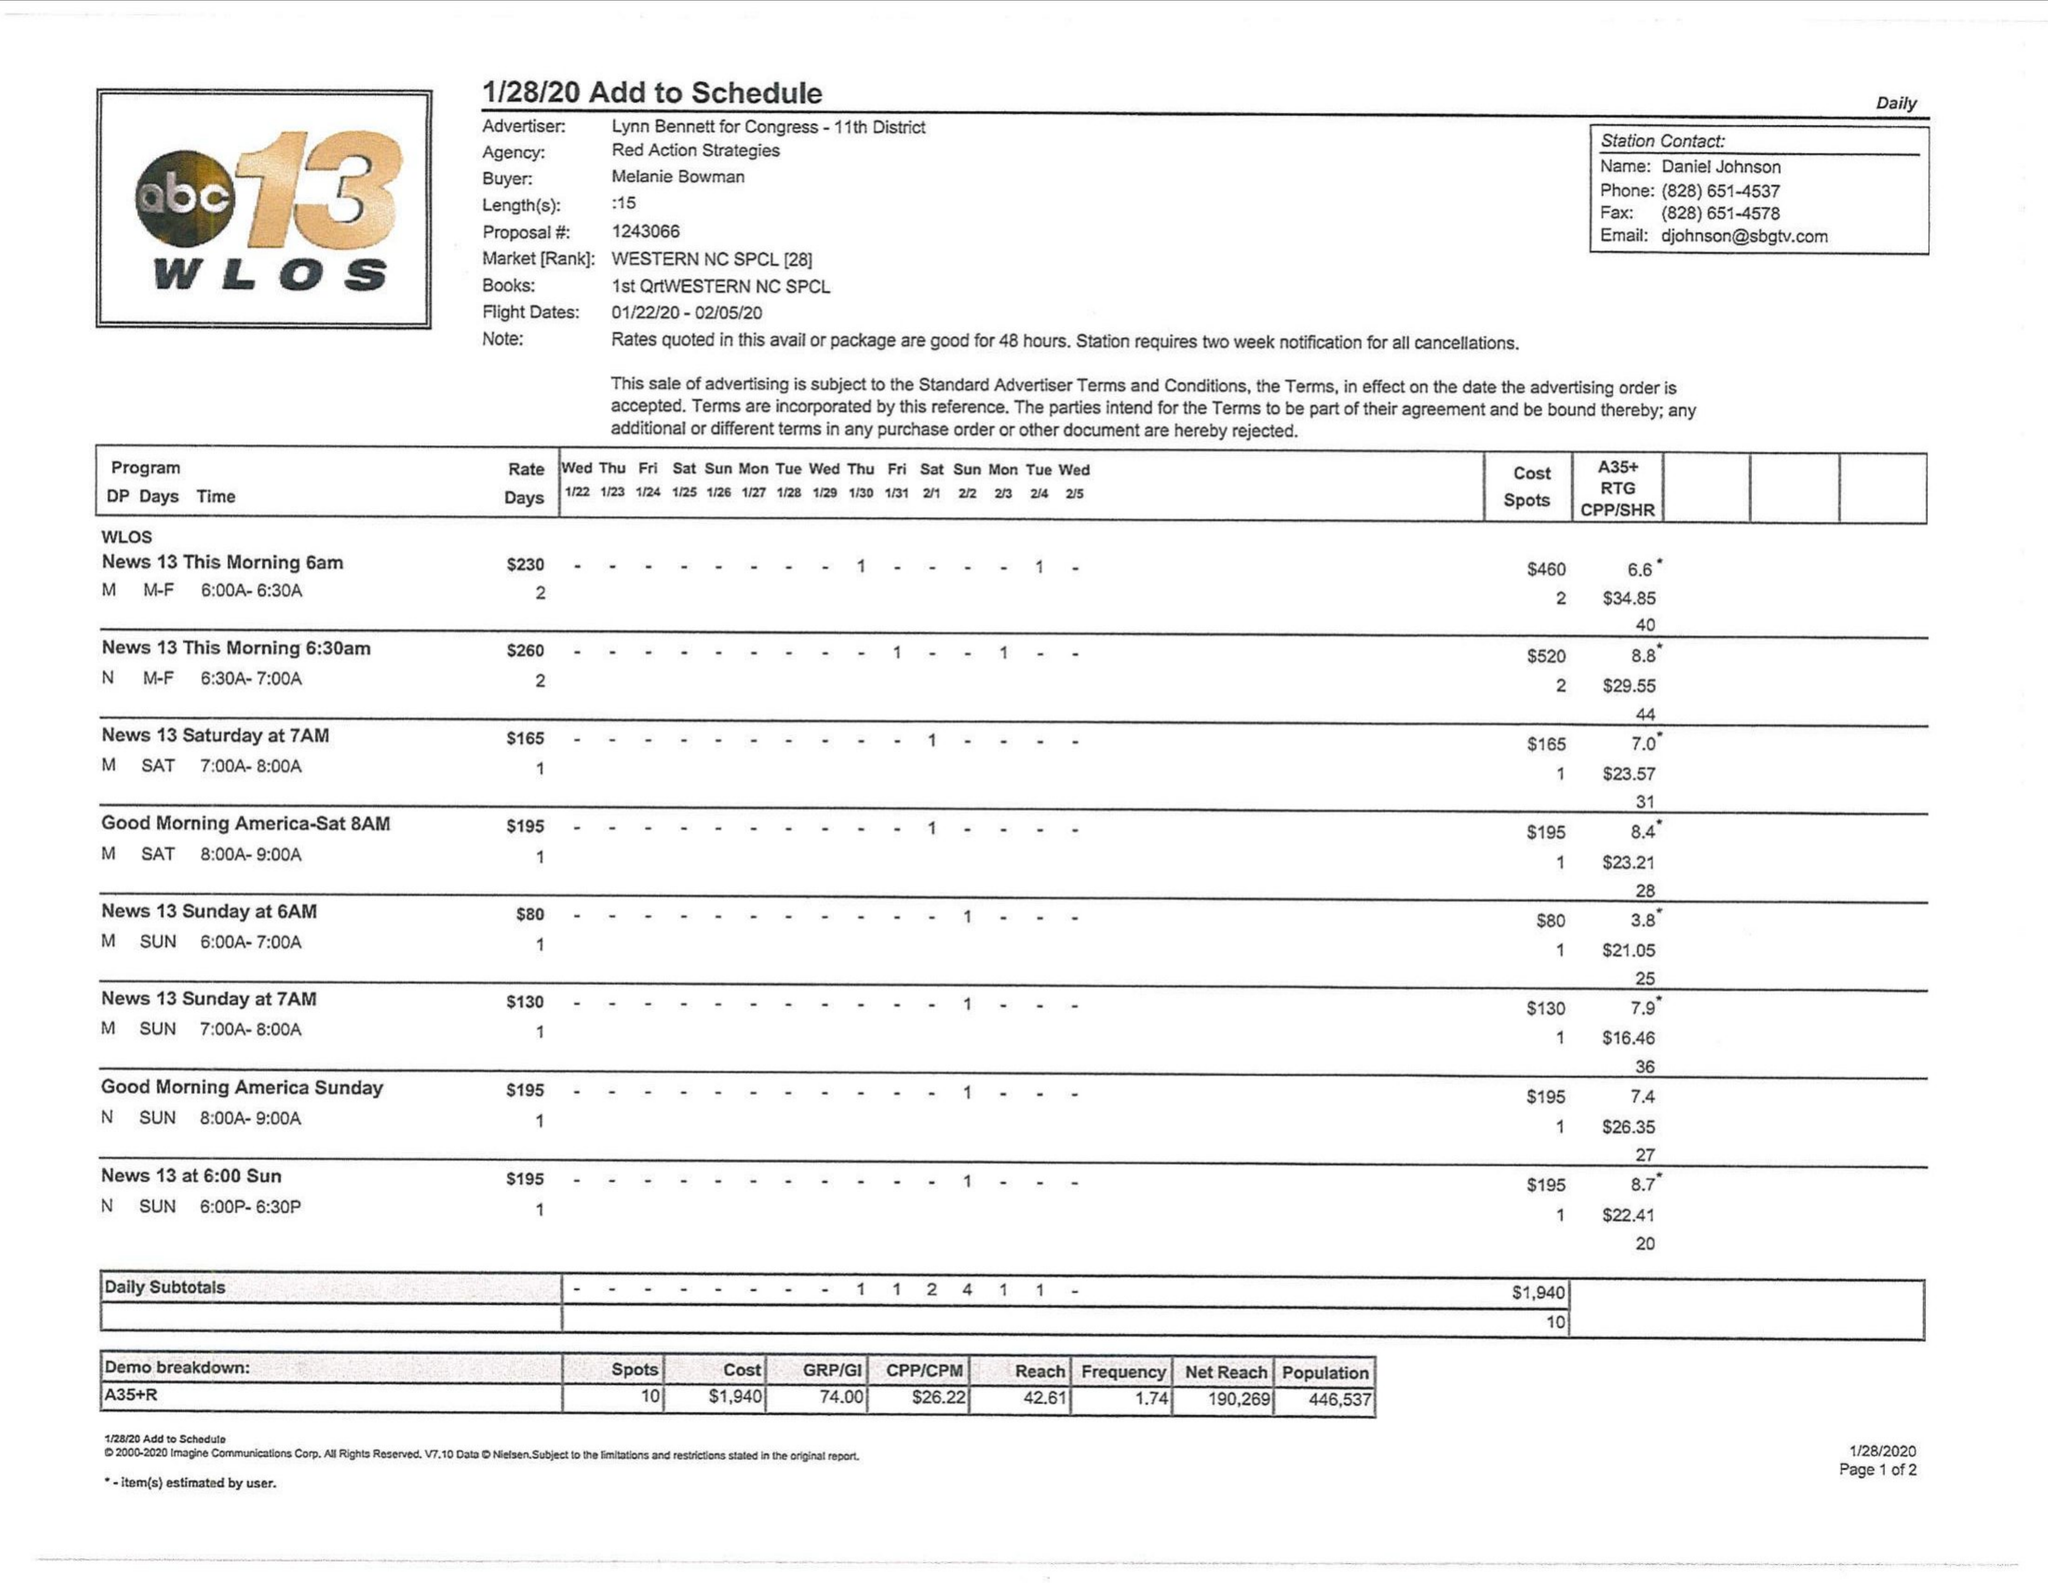What is the value for the gross_amount?
Answer the question using a single word or phrase. 1940.00 